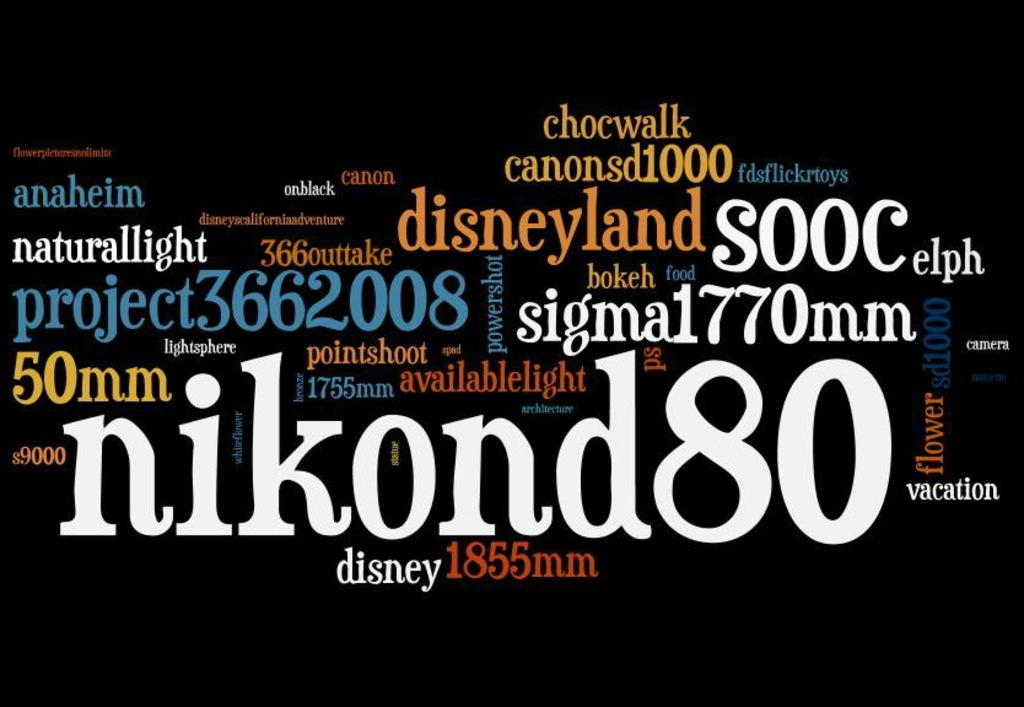<image>
Create a compact narrative representing the image presented. Different sized text nikond80 sigmal1770mm project3662008 et cetera in different colors on black background 